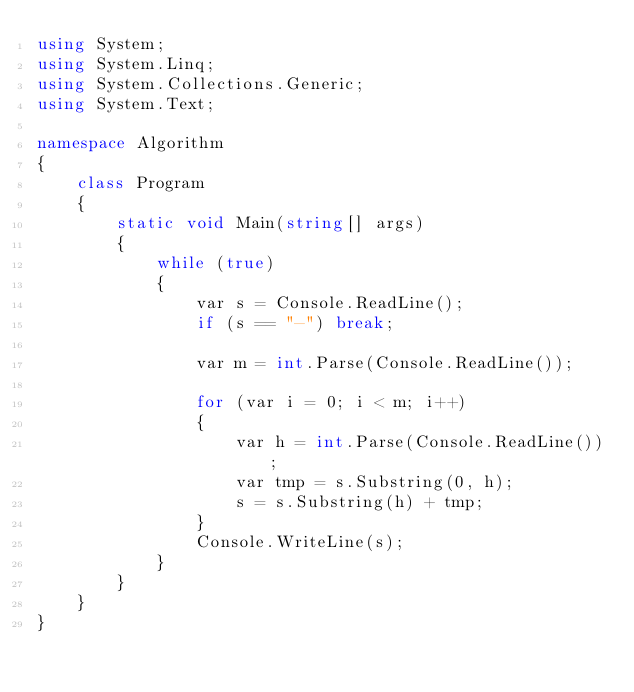Convert code to text. <code><loc_0><loc_0><loc_500><loc_500><_C#_>using System;
using System.Linq;
using System.Collections.Generic;
using System.Text;

namespace Algorithm
{
    class Program
    {
        static void Main(string[] args)
        {
            while (true)
            {
                var s = Console.ReadLine();
                if (s == "-") break;

                var m = int.Parse(Console.ReadLine());

                for (var i = 0; i < m; i++)
                {
                    var h = int.Parse(Console.ReadLine());
                    var tmp = s.Substring(0, h);
                    s = s.Substring(h) + tmp;
                }
                Console.WriteLine(s);
            }
        }
    }
}

</code> 